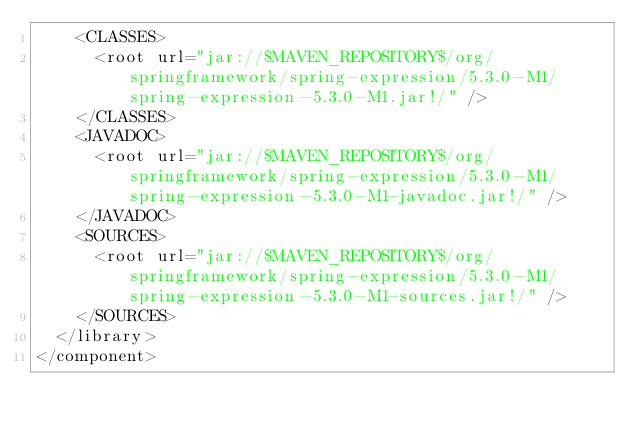<code> <loc_0><loc_0><loc_500><loc_500><_XML_>    <CLASSES>
      <root url="jar://$MAVEN_REPOSITORY$/org/springframework/spring-expression/5.3.0-M1/spring-expression-5.3.0-M1.jar!/" />
    </CLASSES>
    <JAVADOC>
      <root url="jar://$MAVEN_REPOSITORY$/org/springframework/spring-expression/5.3.0-M1/spring-expression-5.3.0-M1-javadoc.jar!/" />
    </JAVADOC>
    <SOURCES>
      <root url="jar://$MAVEN_REPOSITORY$/org/springframework/spring-expression/5.3.0-M1/spring-expression-5.3.0-M1-sources.jar!/" />
    </SOURCES>
  </library>
</component></code> 